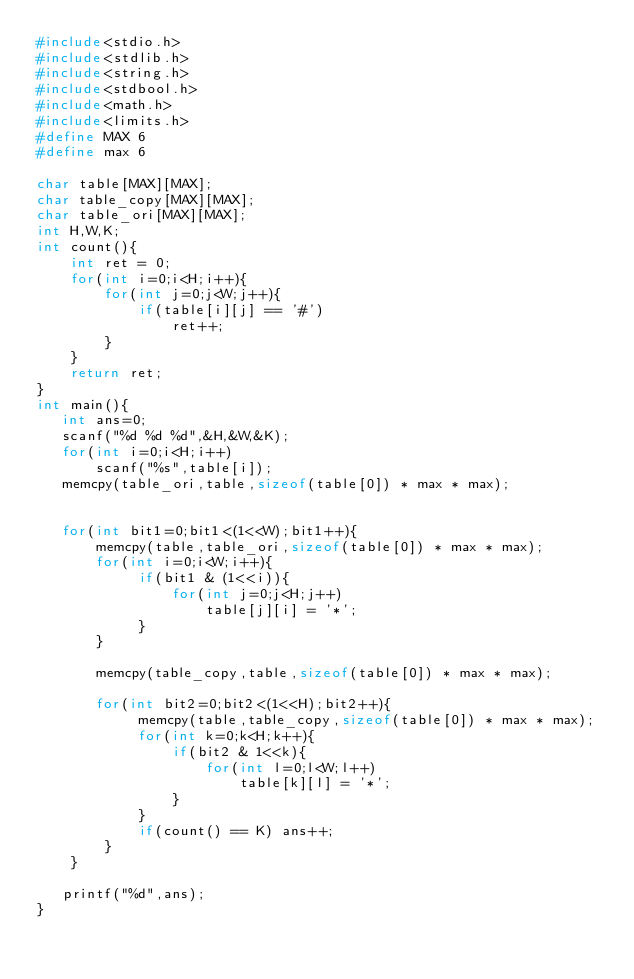Convert code to text. <code><loc_0><loc_0><loc_500><loc_500><_C_>#include<stdio.h>
#include<stdlib.h>
#include<string.h>
#include<stdbool.h>
#include<math.h>
#include<limits.h>
#define MAX 6
#define max 6

char table[MAX][MAX];
char table_copy[MAX][MAX];
char table_ori[MAX][MAX];
int H,W,K;
int count(){
    int ret = 0;
    for(int i=0;i<H;i++){
        for(int j=0;j<W;j++){
            if(table[i][j] == '#')
                ret++;
        }
    }
    return ret;
}
int main(){
   int ans=0;
   scanf("%d %d %d",&H,&W,&K);
   for(int i=0;i<H;i++)
       scanf("%s",table[i]);
   memcpy(table_ori,table,sizeof(table[0]) * max * max);


   for(int bit1=0;bit1<(1<<W);bit1++){
       memcpy(table,table_ori,sizeof(table[0]) * max * max);
       for(int i=0;i<W;i++){
            if(bit1 & (1<<i)){
                for(int j=0;j<H;j++)
                    table[j][i] = '*';
            }
       }

       memcpy(table_copy,table,sizeof(table[0]) * max * max);

       for(int bit2=0;bit2<(1<<H);bit2++){
            memcpy(table,table_copy,sizeof(table[0]) * max * max);
            for(int k=0;k<H;k++){
                if(bit2 & 1<<k){
                    for(int l=0;l<W;l++)
                        table[k][l] = '*';
                }
            }
            if(count() == K) ans++;
        }
    }

   printf("%d",ans);
}
</code> 